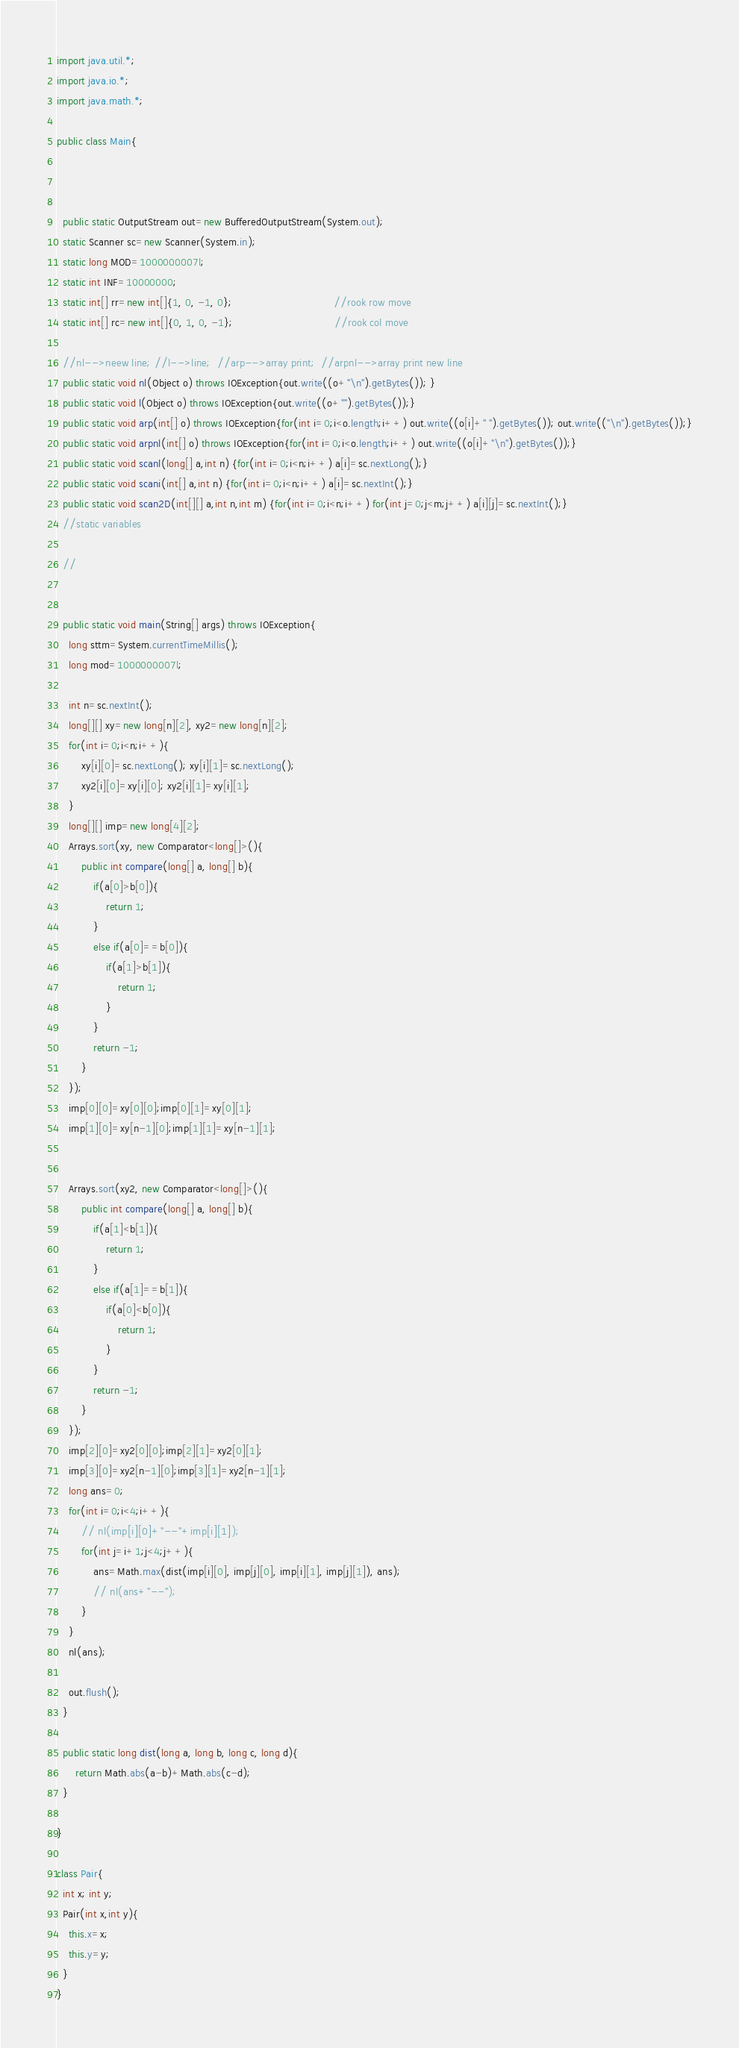<code> <loc_0><loc_0><loc_500><loc_500><_Java_>import java.util.*;
import java.io.*;
import java.math.*;

public class Main{



  public static OutputStream out=new BufferedOutputStream(System.out);
  static Scanner sc=new Scanner(System.in);
  static long MOD=1000000007l;
  static int INF=10000000;
  static int[] rr=new int[]{1, 0, -1, 0};                                 //rook row move
  static int[] rc=new int[]{0, 1, 0, -1};                                 //rook col move

  //nl-->neew line; //l-->line;  //arp-->array print;  //arpnl-->array print new line
  public static void nl(Object o) throws IOException{out.write((o+"\n").getBytes()); }
  public static void l(Object o) throws IOException{out.write((o+"").getBytes());}
  public static void arp(int[] o) throws IOException{for(int i=0;i<o.length;i++) out.write((o[i]+" ").getBytes()); out.write(("\n").getBytes());}
  public static void arpnl(int[] o) throws IOException{for(int i=0;i<o.length;i++) out.write((o[i]+"\n").getBytes());}
  public static void scanl(long[] a,int n) {for(int i=0;i<n;i++) a[i]=sc.nextLong();}
  public static void scani(int[] a,int n) {for(int i=0;i<n;i++) a[i]=sc.nextInt();}
  public static void scan2D(int[][] a,int n,int m) {for(int i=0;i<n;i++) for(int j=0;j<m;j++) a[i][j]=sc.nextInt();}
  //static variables

  //


  public static void main(String[] args) throws IOException{
    long sttm=System.currentTimeMillis();
    long mod=1000000007l;

    int n=sc.nextInt();
    long[][] xy=new long[n][2], xy2=new long[n][2];
    for(int i=0;i<n;i++){
        xy[i][0]=sc.nextLong(); xy[i][1]=sc.nextLong();
        xy2[i][0]=xy[i][0]; xy2[i][1]=xy[i][1];
    }
    long[][] imp=new long[4][2];
    Arrays.sort(xy, new Comparator<long[]>(){
        public int compare(long[] a, long[] b){
            if(a[0]>b[0]){
                return 1;
            }
            else if(a[0]==b[0]){
                if(a[1]>b[1]){
                    return 1;
                }
            }
            return -1;
        }
    });
    imp[0][0]=xy[0][0];imp[0][1]=xy[0][1];
    imp[1][0]=xy[n-1][0];imp[1][1]=xy[n-1][1];


    Arrays.sort(xy2, new Comparator<long[]>(){
        public int compare(long[] a, long[] b){
            if(a[1]<b[1]){
                return 1;
            }
            else if(a[1]==b[1]){
                if(a[0]<b[0]){
                    return 1;
                }
            }
            return -1;
        }
    });
    imp[2][0]=xy2[0][0];imp[2][1]=xy2[0][1];
    imp[3][0]=xy2[n-1][0];imp[3][1]=xy2[n-1][1];
    long ans=0;
    for(int i=0;i<4;i++){
        // nl(imp[i][0]+"--"+imp[i][1]);
        for(int j=i+1;j<4;j++){
            ans=Math.max(dist(imp[i][0], imp[j][0], imp[i][1], imp[j][1]), ans);
            // nl(ans+"--");
        }
    }
    nl(ans);

    out.flush();
  }

  public static long dist(long a, long b, long c, long d){
      return Math.abs(a-b)+Math.abs(c-d);
  }

}

class Pair{
  int x; int y;
  Pair(int x,int y){
    this.x=x;
    this.y=y;
  }
}
</code> 